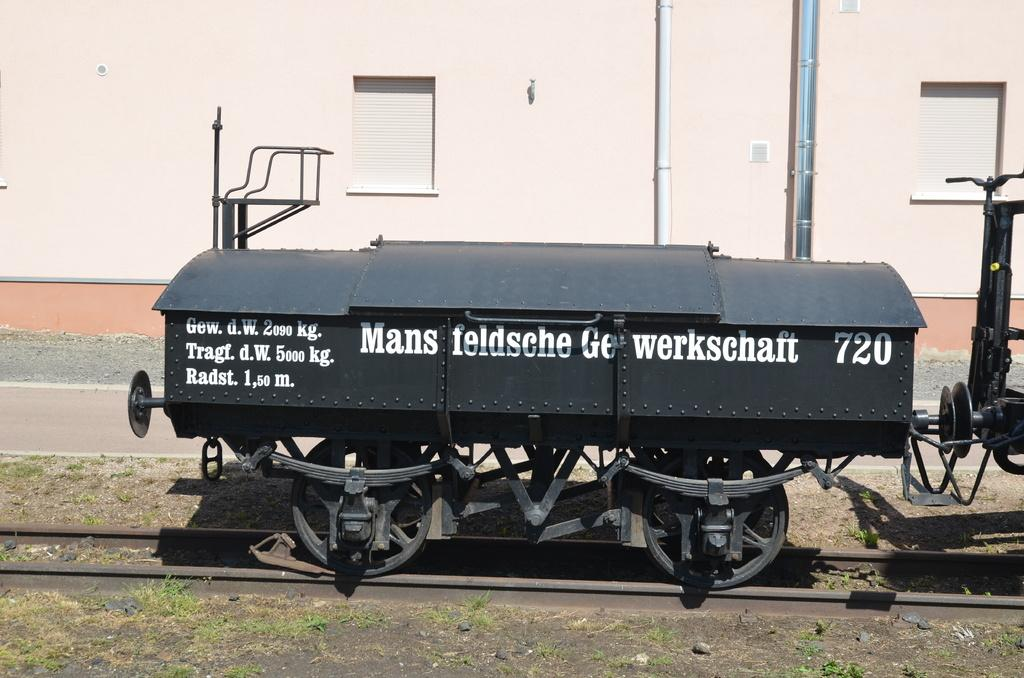What is located on the railway track in the image? There is a bogie on the railway track in the image. Can you describe the background of the image? There may be a building in the background of the image. What can be seen on the right side of the image? There are pipes on the right side of the image. What type of badge is being worn by the expert in the image? There is no expert or badge present in the image. What is the range of the bogie in the image? The bogie in the image is stationary and does not have a range. 